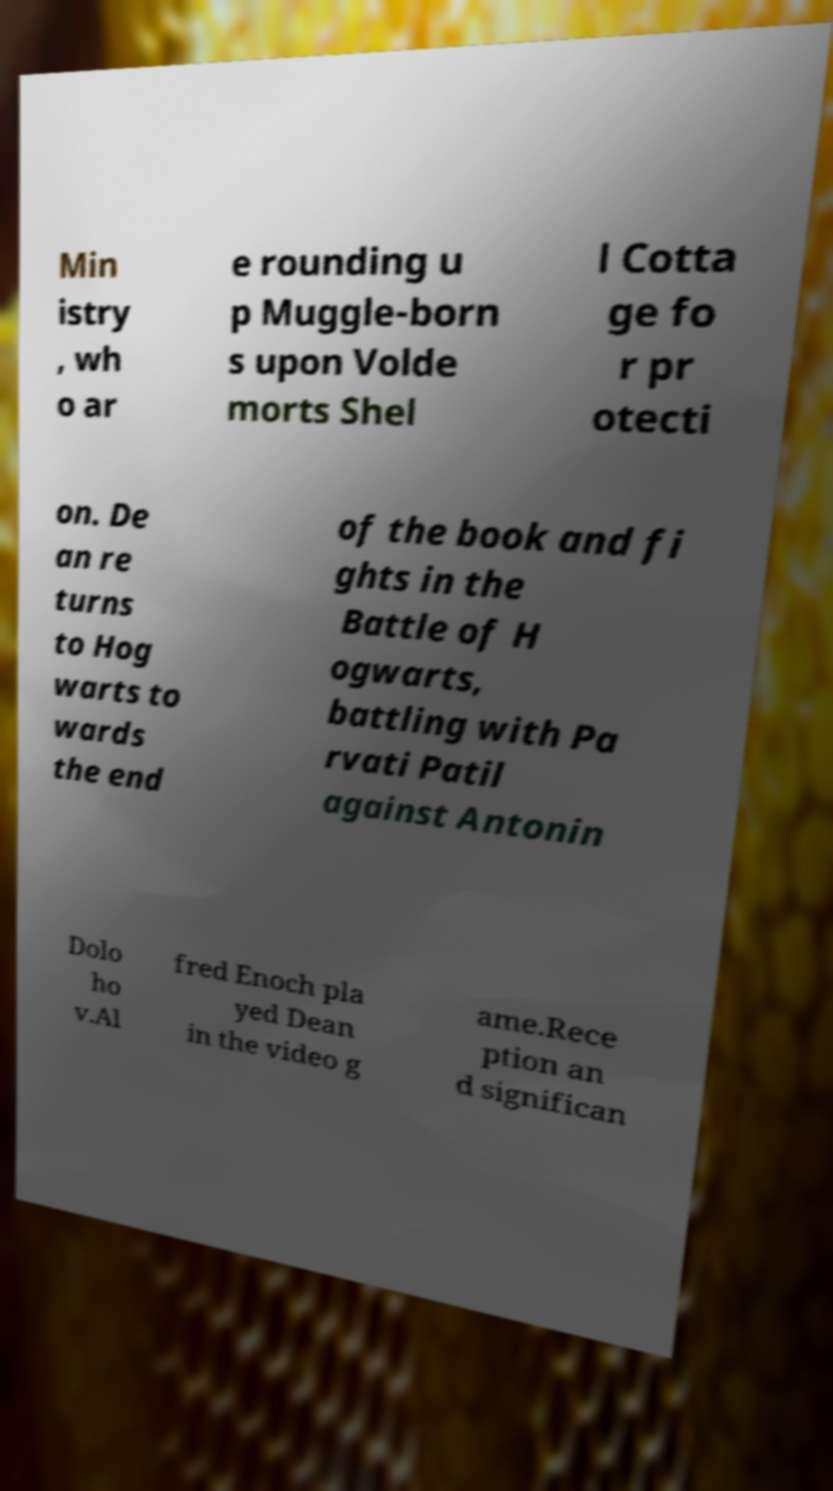I need the written content from this picture converted into text. Can you do that? Min istry , wh o ar e rounding u p Muggle-born s upon Volde morts Shel l Cotta ge fo r pr otecti on. De an re turns to Hog warts to wards the end of the book and fi ghts in the Battle of H ogwarts, battling with Pa rvati Patil against Antonin Dolo ho v.Al fred Enoch pla yed Dean in the video g ame.Rece ption an d significan 